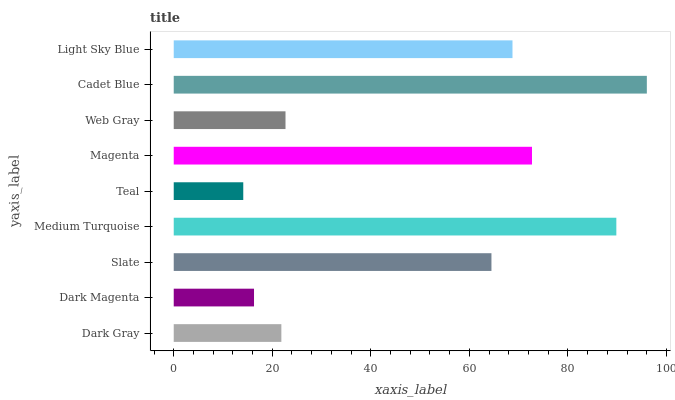Is Teal the minimum?
Answer yes or no. Yes. Is Cadet Blue the maximum?
Answer yes or no. Yes. Is Dark Magenta the minimum?
Answer yes or no. No. Is Dark Magenta the maximum?
Answer yes or no. No. Is Dark Gray greater than Dark Magenta?
Answer yes or no. Yes. Is Dark Magenta less than Dark Gray?
Answer yes or no. Yes. Is Dark Magenta greater than Dark Gray?
Answer yes or no. No. Is Dark Gray less than Dark Magenta?
Answer yes or no. No. Is Slate the high median?
Answer yes or no. Yes. Is Slate the low median?
Answer yes or no. Yes. Is Dark Magenta the high median?
Answer yes or no. No. Is Magenta the low median?
Answer yes or no. No. 